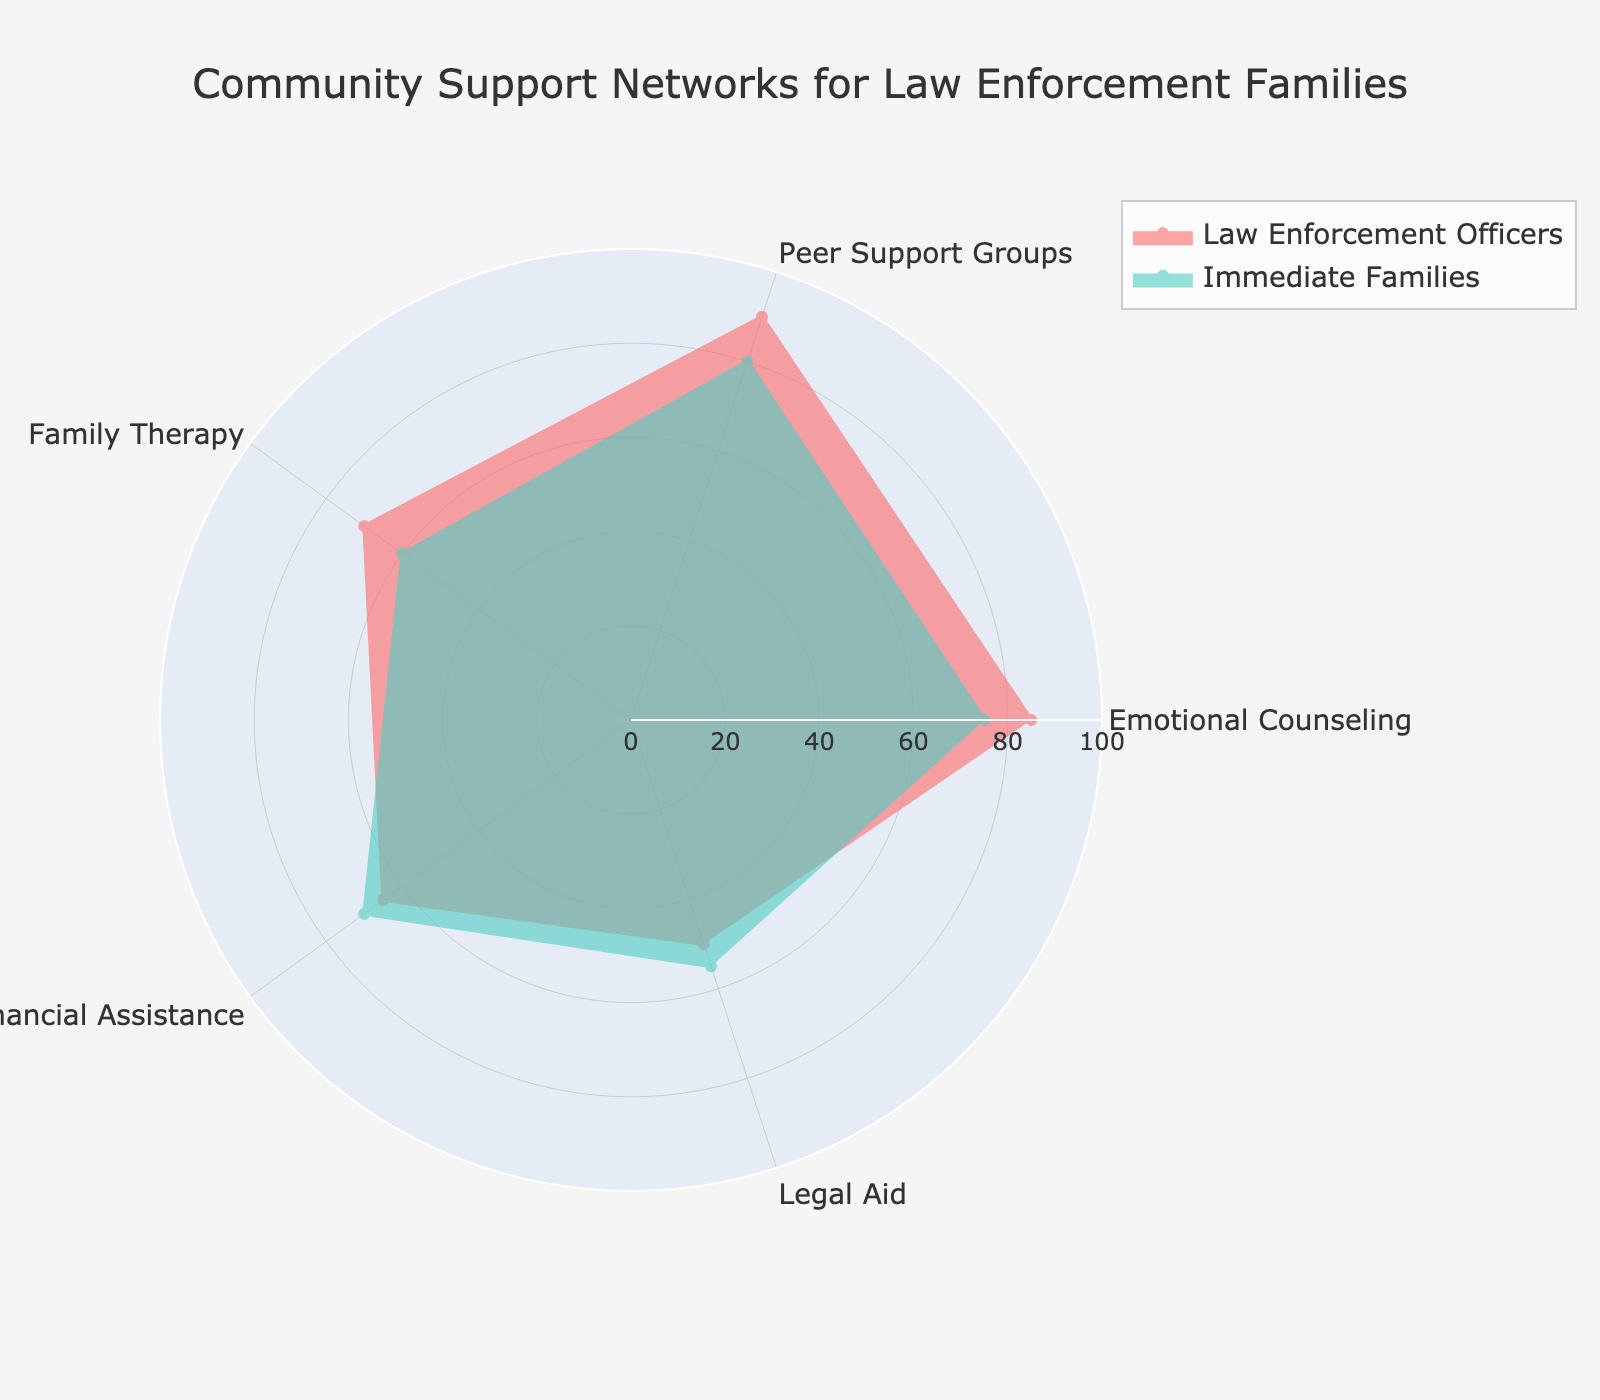What is the title of the radar chart? The title is usually at the top of the chart. The figure title is "Community Support Networks for Law Enforcement Families"
Answer: Community Support Networks for Law Enforcement Families Which two groups are depicted in the radar chart? The groups are mentioned in the legend of the chart. The two groups are "Law Enforcement Officers" and "Immediate Families".
Answer: Law Enforcement Officers, Immediate Families Which service has the highest frequency for Law Enforcement Officers? Examine the radial positions of the points for "Law Enforcement Officers". The highest value is 90 for "Peer Support Groups".
Answer: Peer Support Groups What is the average frequency of services used by Immediate Families? Add up the values for "Immediate Families" (75 + 80 + 60 + 70 + 55) and divide by the number of services (5). This results in an average of (340/5) = 68.
Answer: 68 Which group uses Financial Assistance services more frequently? Compare the values for "Financial Assistance" for both groups. "Immediate Family" uses it at 70 and "Law Enforcement Officers" at 65. Immediate Families use it more frequently.
Answer: Immediate Families Which service shows the greatest difference in usage between Law Enforcement Officers and Immediate Families? Compute the absolute differences for each service. The largest difference is in "Peer Support Groups" (90 - 80 = 10).
Answer: Peer Support Groups If you were to find the total usage of Peer Support Groups and Legal Aid for both groups, what would it be? Add the values for "Peer Support Groups" and "Legal Aid" for both groups: (90 + 50 for Law Enforcement Officers and 80 + 55 for Immediate Families). Total is (140 for Law Enforcement Officers + 135 for Immediate Families) = 275.
Answer: 275 Are there any services where the usage is equally frequent for both groups? Compare the values for each service. All values are different between the two groups, indicating none are equally frequent.
Answer: No Which service has the lowest frequency for both Law Enforcement Officers and Immediate Families? Identify the smallest values in the "Law Enforcement Officers" and "Immediate Families" series. For both groups, "Legal Aid" has the lowest frequency at 50 and 55, respectively.
Answer: Legal Aid What can be inferred about the difference in use of Emotional Counseling between Law Enforcement Officers and Immediate Families? The value for Emotional Counseling for Law Enforcement Officers is 85 and for Immediate Families is 75. The difference is 10. Law Enforcement Officers use Emotional Counseling more frequently by 10 units.
Answer: Law Enforcement Officers use Emotional Counseling 10 units more 